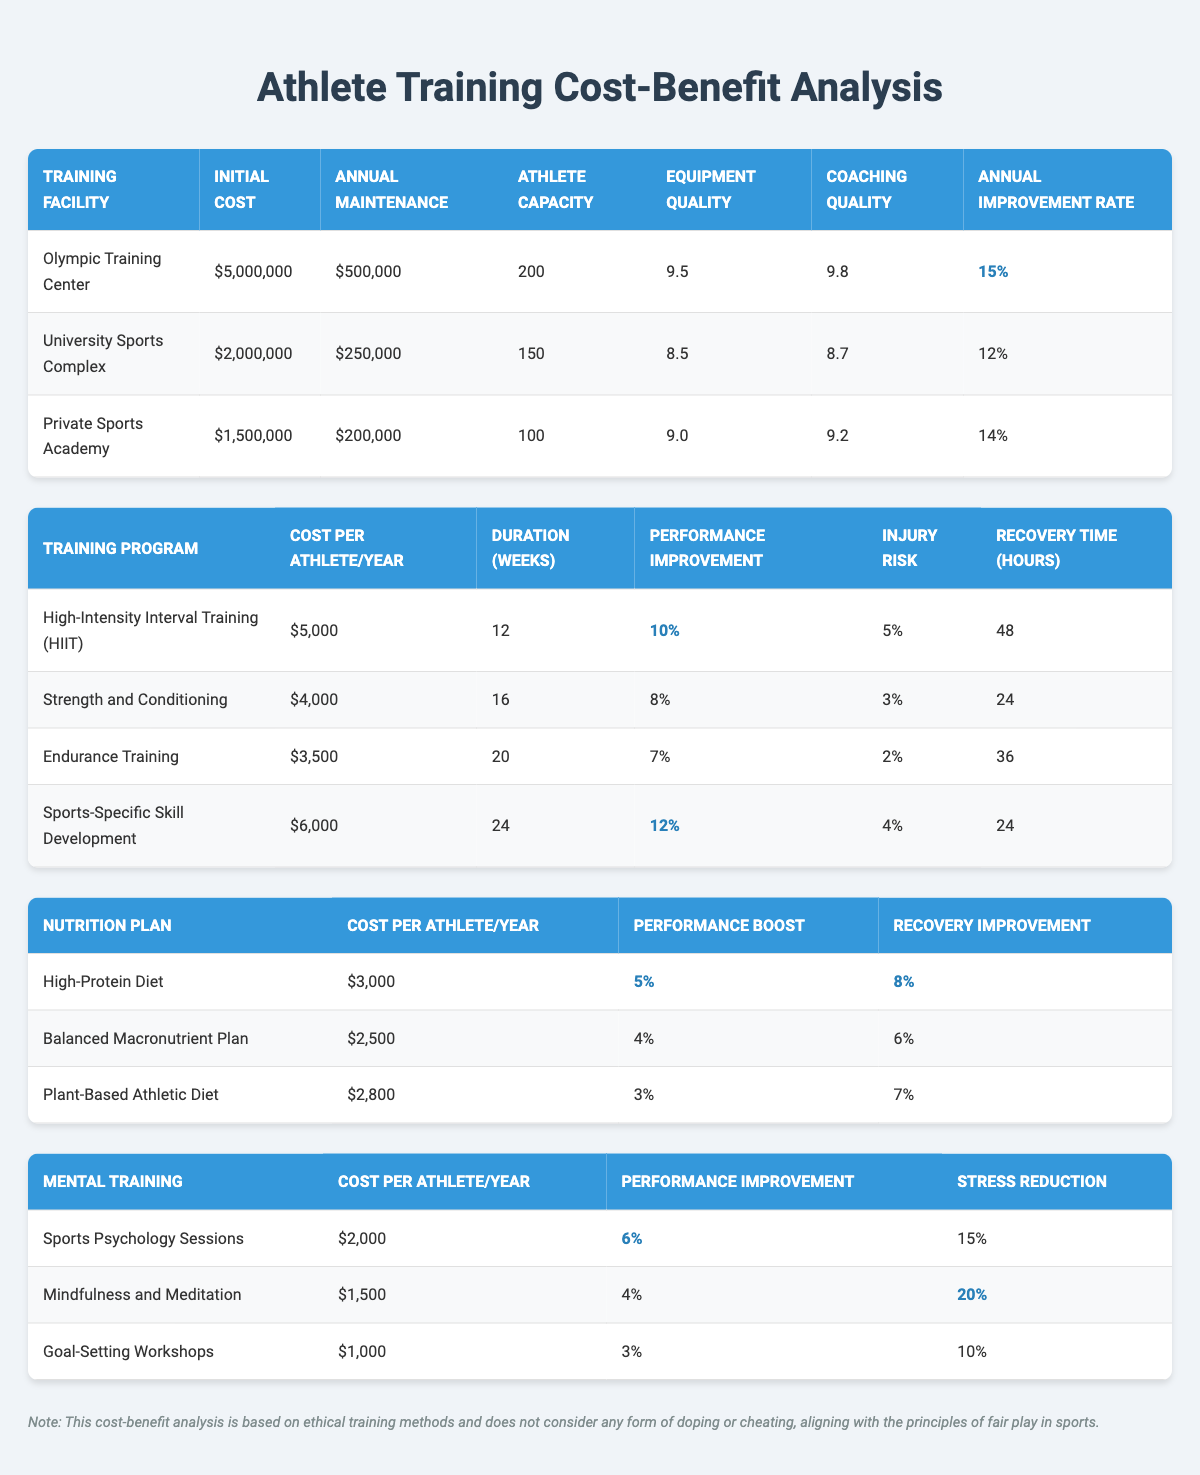What is the initial cost of the Olympic Training Center? The initial cost of the Olympic Training Center is explicitly listed in the table under the "Initial Cost" column for that facility. The value provided is $5,000,000.
Answer: $5,000,000 Which training program has the highest performance improvement percentage? By examining the "Performance Improvement" column in the training programs table, the highest value is found for "High-Intensity Interval Training (HIIT)", which has an improvement of 10%.
Answer: High-Intensity Interval Training (HIIT) What is the total cost for an athlete to undergo Sports-Specific Skill Development for one year? The cost per athlete per year for Sports-Specific Skill Development is noted in the training programs table, which is $6,000 for one year.
Answer: $6,000 Is the injury risk associated with Endurance Training higher than that for Strength and Conditioning? The injury risk for Endurance Training is 2%, while for Strength and Conditioning it is 3%. Since 2% is less than 3%, the statement is false.
Answer: No What is the average cost per athlete per year for nutrition plans? The total costs for the nutrition plans are: High-Protein Diet ($3,000), Balanced Macronutrient Plan ($2,500), and Plant-Based Athletic Diet ($2,800). Adding these gives a total of $8,300, and dividing by 3 (number of plans) gives an average of $2,766.67, which rounds to approximately $2,767.
Answer: $2,767 Which facility has the best coaching staff quality? By comparing the "Coaching Quality" column of all training facilities, the Olympic Training Center scores 9.8, which is the highest value listed among the facilities.
Answer: Olympic Training Center What is the percentage of performance improvement associated with the Balanced Macronutrient Plan? The performance boost for the Balanced Macronutrient Plan is detailed in the nutrition plans table, showing a value of 4%.
Answer: 4% Does the Private Sports Academy have a higher athlete capacity than the University Sports Complex? The athlete capacity for Private Sports Academy is 100 and for University Sports Complex is 150. Since 100 is less than 150, the statement is false.
Answer: No What is the combined cost per athlete per year for High-Intensity Interval Training (HIIT) and Sports-Specific Skill Development? The cost for HIIT is $5,000 and for Sports-Specific Skill Development it's $6,000. Adding these costs together results in $5,000 + $6,000 = $11,000.
Answer: $11,000 What is the recovery time in hours for Strength and Conditioning? The recovery time associated with Strength and Conditioning is clearly mentioned in the training programs table, showing a value of 24 hours.
Answer: 24 hours 